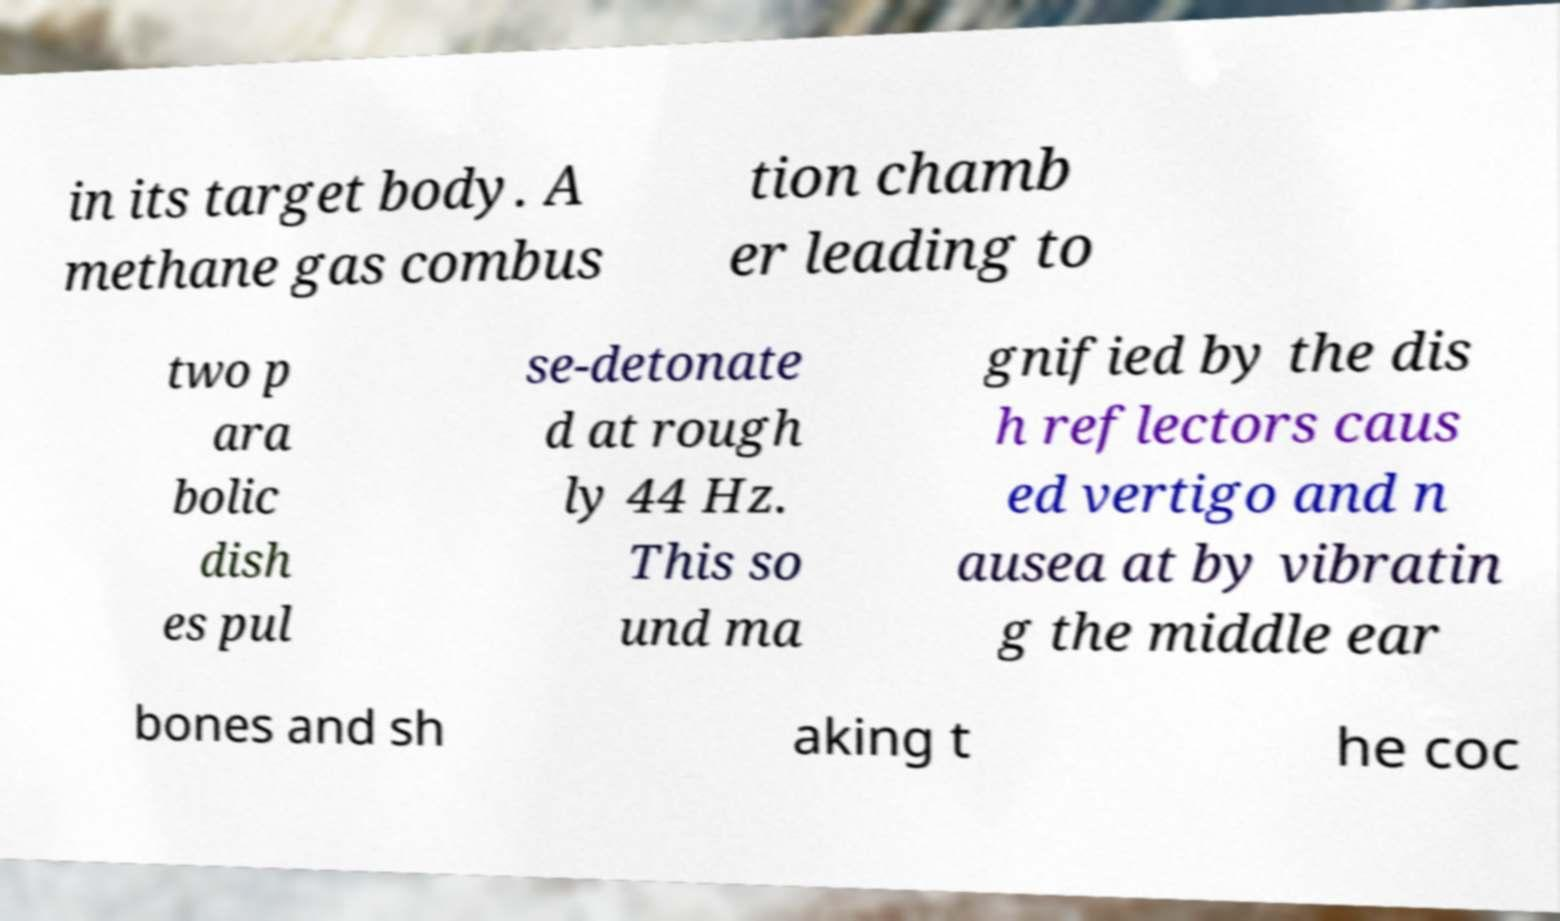Can you accurately transcribe the text from the provided image for me? in its target body. A methane gas combus tion chamb er leading to two p ara bolic dish es pul se-detonate d at rough ly 44 Hz. This so und ma gnified by the dis h reflectors caus ed vertigo and n ausea at by vibratin g the middle ear bones and sh aking t he coc 